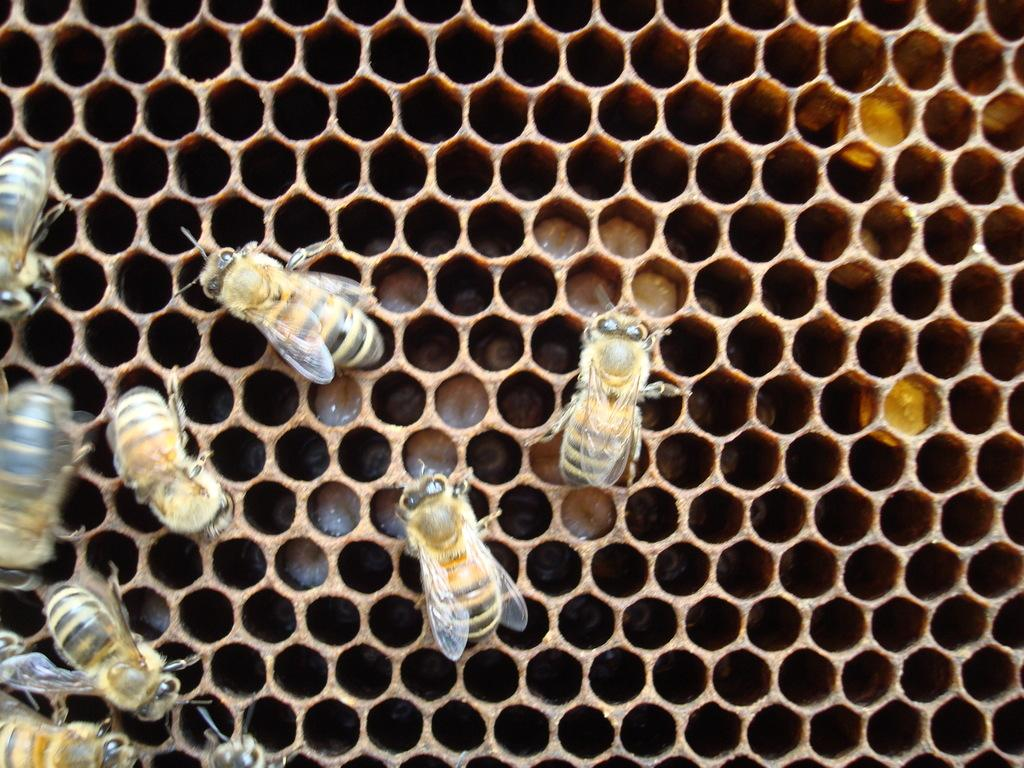What type of insects are present in the image? There are honey bees in the image. Where are the honey bees located? The honey bees are on a nest. What type of train can be seen in the image? There is no train present in the image; it features honey bees on a nest. How many goldfish are visible in the image? There are no goldfish present in the image; it features honey bees on a nest. 